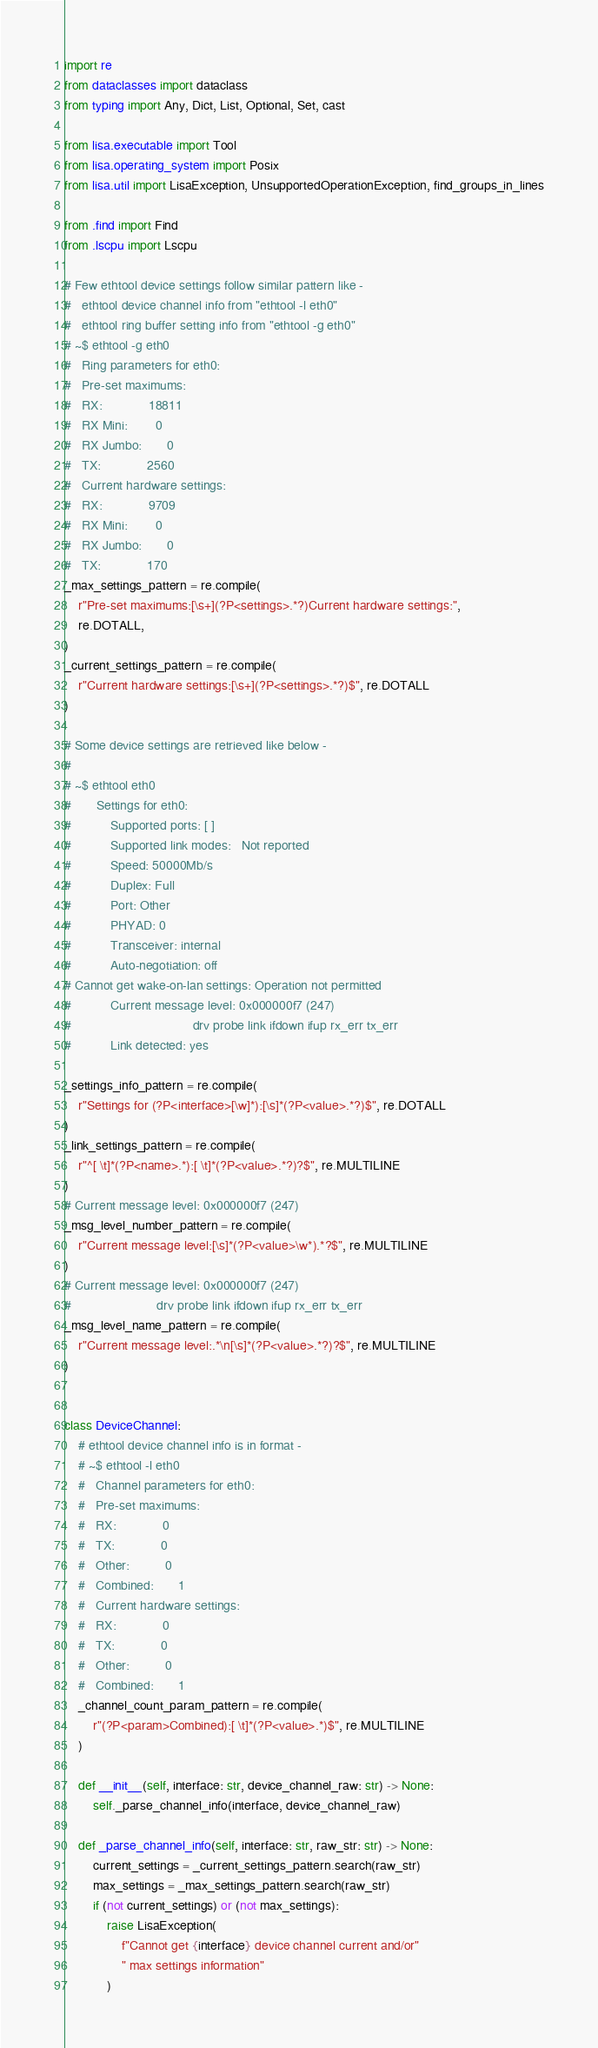Convert code to text. <code><loc_0><loc_0><loc_500><loc_500><_Python_>import re
from dataclasses import dataclass
from typing import Any, Dict, List, Optional, Set, cast

from lisa.executable import Tool
from lisa.operating_system import Posix
from lisa.util import LisaException, UnsupportedOperationException, find_groups_in_lines

from .find import Find
from .lscpu import Lscpu

# Few ethtool device settings follow similar pattern like -
#   ethtool device channel info from "ethtool -l eth0"
#   ethtool ring buffer setting info from "ethtool -g eth0"
# ~$ ethtool -g eth0
#   Ring parameters for eth0:
#   Pre-set maximums:
#   RX:             18811
#   RX Mini:        0
#   RX Jumbo:       0
#   TX:             2560
#   Current hardware settings:
#   RX:             9709
#   RX Mini:        0
#   RX Jumbo:       0
#   TX:             170
_max_settings_pattern = re.compile(
    r"Pre-set maximums:[\s+](?P<settings>.*?)Current hardware settings:",
    re.DOTALL,
)
_current_settings_pattern = re.compile(
    r"Current hardware settings:[\s+](?P<settings>.*?)$", re.DOTALL
)

# Some device settings are retrieved like below -
#
# ~$ ethtool eth0
#       Settings for eth0:
#           Supported ports: [ ]
#           Supported link modes:   Not reported
#           Speed: 50000Mb/s
#           Duplex: Full
#           Port: Other
#           PHYAD: 0
#           Transceiver: internal
#           Auto-negotiation: off
# Cannot get wake-on-lan settings: Operation not permitted
#           Current message level: 0x000000f7 (247)
#                                  drv probe link ifdown ifup rx_err tx_err
#           Link detected: yes

_settings_info_pattern = re.compile(
    r"Settings for (?P<interface>[\w]*):[\s]*(?P<value>.*?)$", re.DOTALL
)
_link_settings_pattern = re.compile(
    r"^[ \t]*(?P<name>.*):[ \t]*(?P<value>.*?)?$", re.MULTILINE
)
# Current message level: 0x000000f7 (247)
_msg_level_number_pattern = re.compile(
    r"Current message level:[\s]*(?P<value>\w*).*?$", re.MULTILINE
)
# Current message level: 0x000000f7 (247)
#                        drv probe link ifdown ifup rx_err tx_err
_msg_level_name_pattern = re.compile(
    r"Current message level:.*\n[\s]*(?P<value>.*?)?$", re.MULTILINE
)


class DeviceChannel:
    # ethtool device channel info is in format -
    # ~$ ethtool -l eth0
    #   Channel parameters for eth0:
    #   Pre-set maximums:
    #   RX:             0
    #   TX:             0
    #   Other:          0
    #   Combined:       1
    #   Current hardware settings:
    #   RX:             0
    #   TX:             0
    #   Other:          0
    #   Combined:       1
    _channel_count_param_pattern = re.compile(
        r"(?P<param>Combined):[ \t]*(?P<value>.*)$", re.MULTILINE
    )

    def __init__(self, interface: str, device_channel_raw: str) -> None:
        self._parse_channel_info(interface, device_channel_raw)

    def _parse_channel_info(self, interface: str, raw_str: str) -> None:
        current_settings = _current_settings_pattern.search(raw_str)
        max_settings = _max_settings_pattern.search(raw_str)
        if (not current_settings) or (not max_settings):
            raise LisaException(
                f"Cannot get {interface} device channel current and/or"
                " max settings information"
            )
</code> 